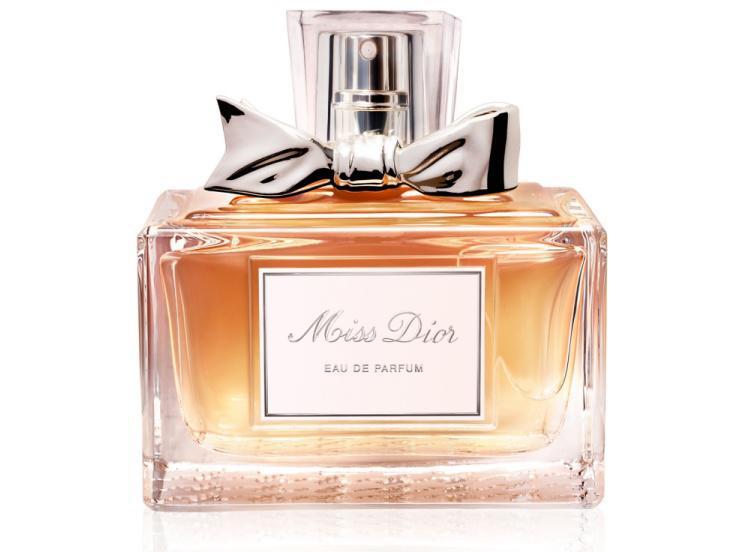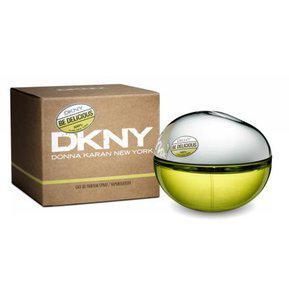The first image is the image on the left, the second image is the image on the right. For the images displayed, is the sentence "The left image contains only two fragrance-related objects, which are side-by-side but not touching and include a lavender bottle with a metallic element." factually correct? Answer yes or no. No. The first image is the image on the left, the second image is the image on the right. For the images shown, is this caption "There is a single vial near its box in one of the images." true? Answer yes or no. Yes. The first image is the image on the left, the second image is the image on the right. Evaluate the accuracy of this statement regarding the images: "There is a bottle shaped like an animal.". Is it true? Answer yes or no. No. The first image is the image on the left, the second image is the image on the right. For the images shown, is this caption "One image includes a fragrance bottle with a shape inspired by some type of animal." true? Answer yes or no. No. 